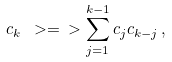Convert formula to latex. <formula><loc_0><loc_0><loc_500><loc_500>c _ { k } \ > = \ > \sum _ { j = 1 } ^ { k - 1 } c _ { j } c _ { k - j } \, ,</formula> 